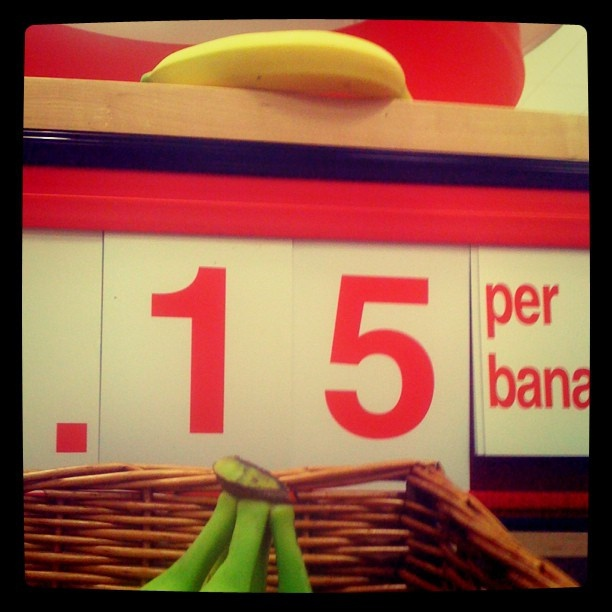Describe the objects in this image and their specific colors. I can see banana in black, orange, khaki, and red tones, banana in black, olive, and darkgreen tones, banana in black and olive tones, and banana in black, olive, darkgreen, and maroon tones in this image. 